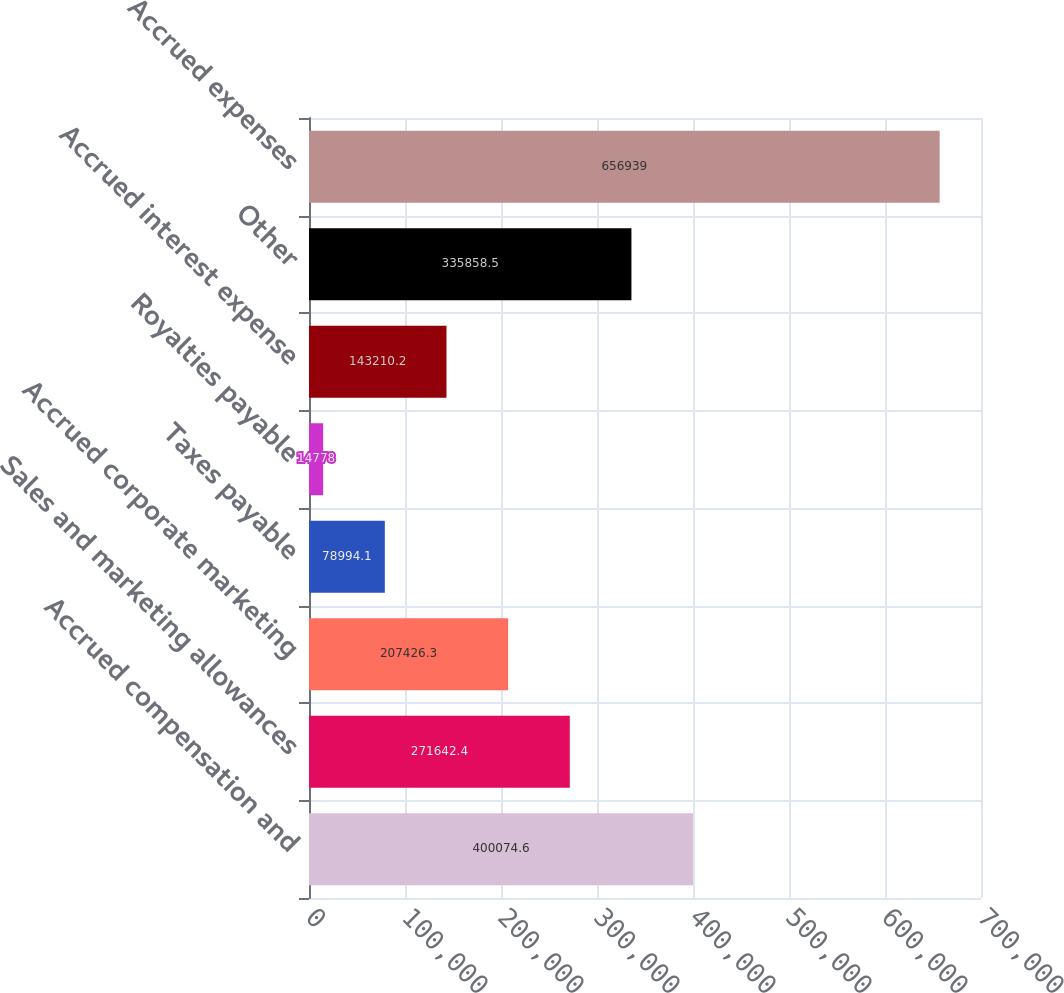<chart> <loc_0><loc_0><loc_500><loc_500><bar_chart><fcel>Accrued compensation and<fcel>Sales and marketing allowances<fcel>Accrued corporate marketing<fcel>Taxes payable<fcel>Royalties payable<fcel>Accrued interest expense<fcel>Other<fcel>Accrued expenses<nl><fcel>400075<fcel>271642<fcel>207426<fcel>78994.1<fcel>14778<fcel>143210<fcel>335858<fcel>656939<nl></chart> 